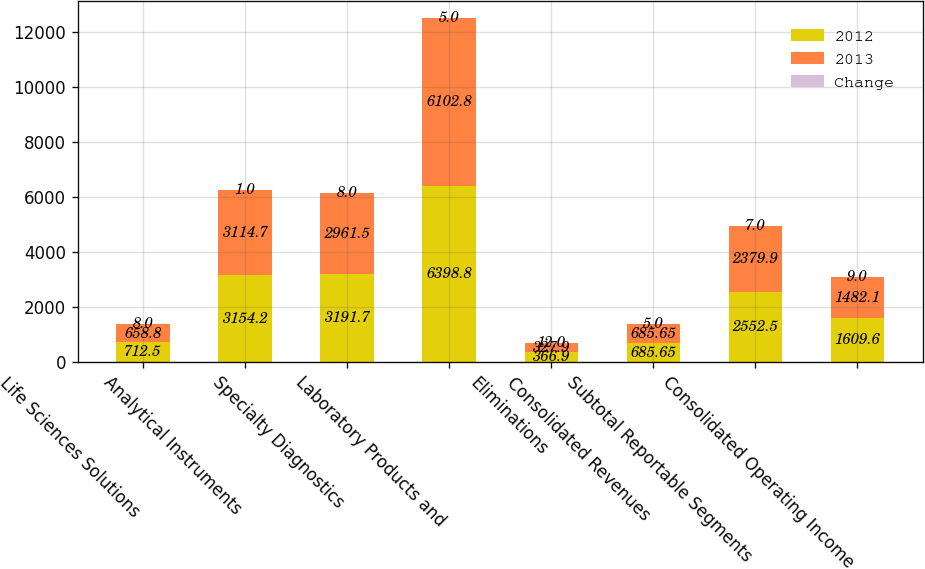<chart> <loc_0><loc_0><loc_500><loc_500><stacked_bar_chart><ecel><fcel>Life Sciences Solutions<fcel>Analytical Instruments<fcel>Specialty Diagnostics<fcel>Laboratory Products and<fcel>Eliminations<fcel>Consolidated Revenues<fcel>Subtotal Reportable Segments<fcel>Consolidated Operating Income<nl><fcel>2012<fcel>712.5<fcel>3154.2<fcel>3191.7<fcel>6398.8<fcel>366.9<fcel>685.65<fcel>2552.5<fcel>1609.6<nl><fcel>2013<fcel>658.8<fcel>3114.7<fcel>2961.5<fcel>6102.8<fcel>327.9<fcel>685.65<fcel>2379.9<fcel>1482.1<nl><fcel>Change<fcel>8<fcel>1<fcel>8<fcel>5<fcel>12<fcel>5<fcel>7<fcel>9<nl></chart> 